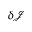<formula> <loc_0><loc_0><loc_500><loc_500>\delta { \mathcal { J } }</formula> 